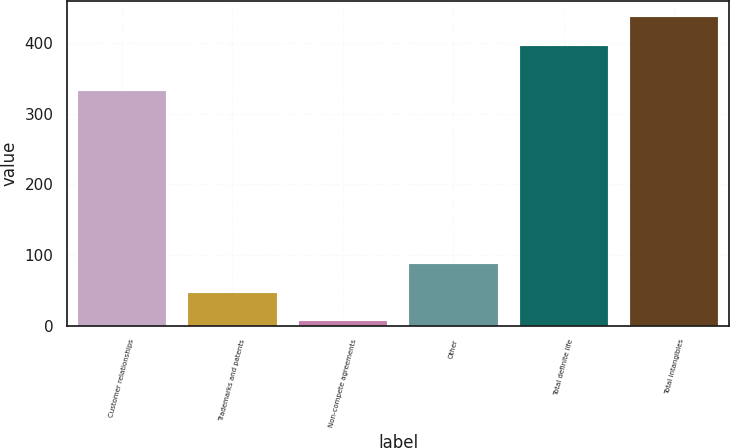Convert chart to OTSL. <chart><loc_0><loc_0><loc_500><loc_500><bar_chart><fcel>Customer relationships<fcel>Trademarks and patents<fcel>Non-compete agreements<fcel>Other<fcel>Total definite life<fcel>Total intangibles<nl><fcel>332<fcel>46.8<fcel>6<fcel>87.6<fcel>397<fcel>437.8<nl></chart> 